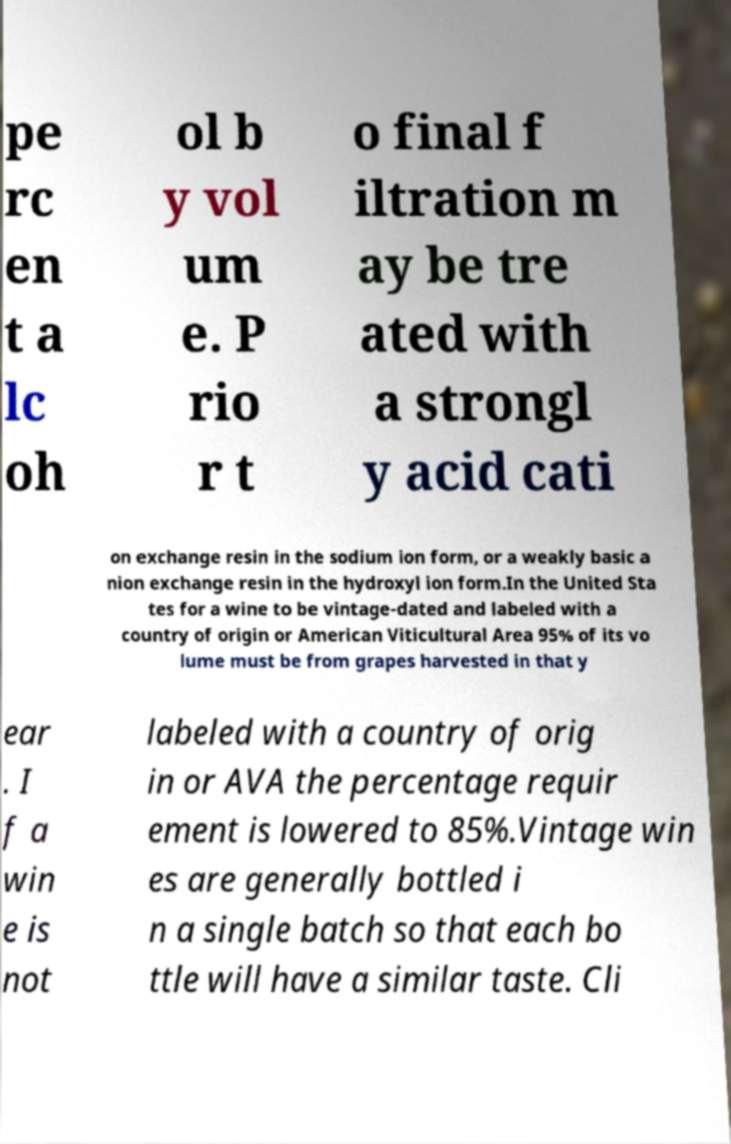Could you extract and type out the text from this image? pe rc en t a lc oh ol b y vol um e. P rio r t o final f iltration m ay be tre ated with a strongl y acid cati on exchange resin in the sodium ion form, or a weakly basic a nion exchange resin in the hydroxyl ion form.In the United Sta tes for a wine to be vintage-dated and labeled with a country of origin or American Viticultural Area 95% of its vo lume must be from grapes harvested in that y ear . I f a win e is not labeled with a country of orig in or AVA the percentage requir ement is lowered to 85%.Vintage win es are generally bottled i n a single batch so that each bo ttle will have a similar taste. Cli 